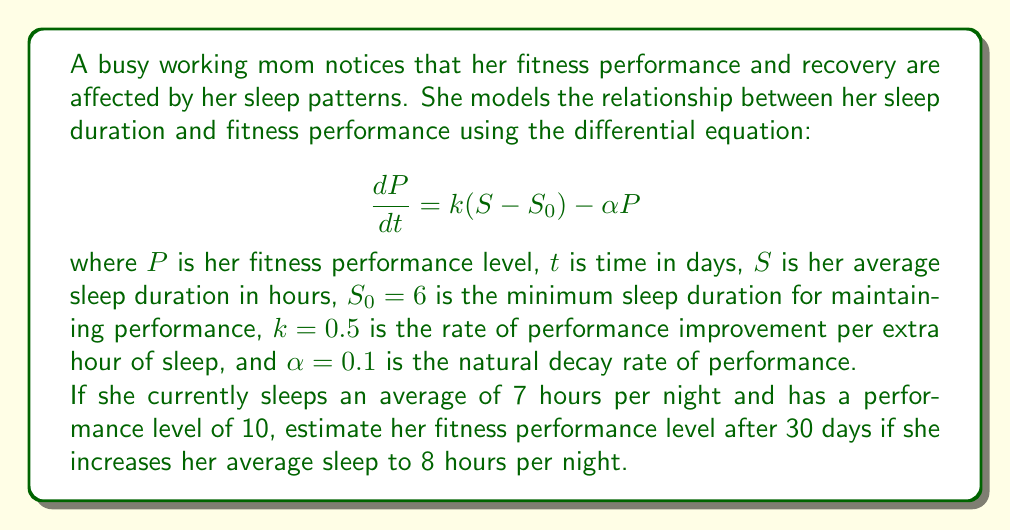What is the answer to this math problem? To solve this problem, we need to follow these steps:

1. Identify the type of differential equation:
   This is a first-order linear differential equation.

2. Find the equilibrium solution:
   At equilibrium, $\frac{dP}{dt} = 0$, so:
   $$0 = k(S - S_0) - \alpha P_{eq}$$
   $$\alpha P_{eq} = k(S - S_0)$$
   $$P_{eq} = \frac{k(S - S_0)}{\alpha}$$

3. Solve the differential equation:
   The general solution is:
   $$P(t) = P_{eq} + (P_0 - P_{eq})e^{-\alpha t}$$
   where $P_0$ is the initial performance level.

4. Calculate the equilibrium performance for 8 hours of sleep:
   $$P_{eq} = \frac{0.5(8 - 6)}{0.1} = 10$$

5. Apply the solution with given values:
   $P_0 = 10$, $t = 30$, $\alpha = 0.1$
   $$P(30) = 10 + (10 - 10)e^{-0.1 \cdot 30}$$
   $$P(30) = 10$$

The performance level remains at 10 because the initial performance was already at the new equilibrium level for 8 hours of sleep.
Answer: After 30 days of sleeping 8 hours per night, the estimated fitness performance level will be 10. 